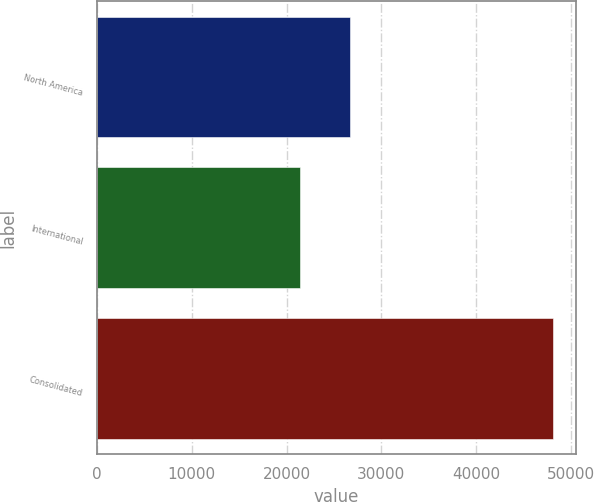<chart> <loc_0><loc_0><loc_500><loc_500><bar_chart><fcel>North America<fcel>International<fcel>Consolidated<nl><fcel>26705<fcel>21372<fcel>48077<nl></chart> 